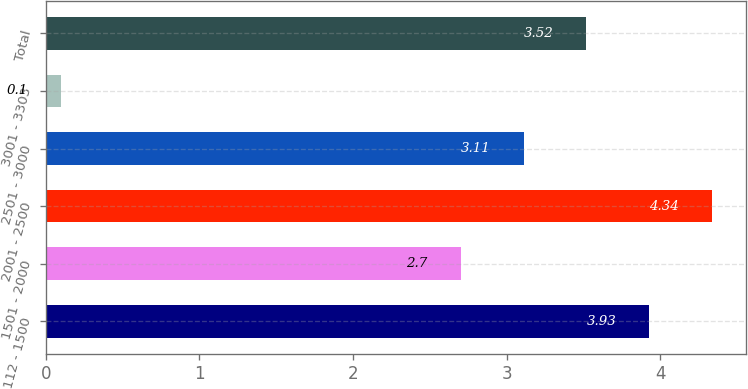Convert chart. <chart><loc_0><loc_0><loc_500><loc_500><bar_chart><fcel>112 - 1500<fcel>1501 - 2000<fcel>2001 - 2500<fcel>2501 - 3000<fcel>3001 - 3303<fcel>Total<nl><fcel>3.93<fcel>2.7<fcel>4.34<fcel>3.11<fcel>0.1<fcel>3.52<nl></chart> 